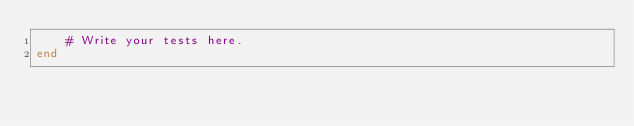<code> <loc_0><loc_0><loc_500><loc_500><_Julia_>    # Write your tests here.
end
</code> 